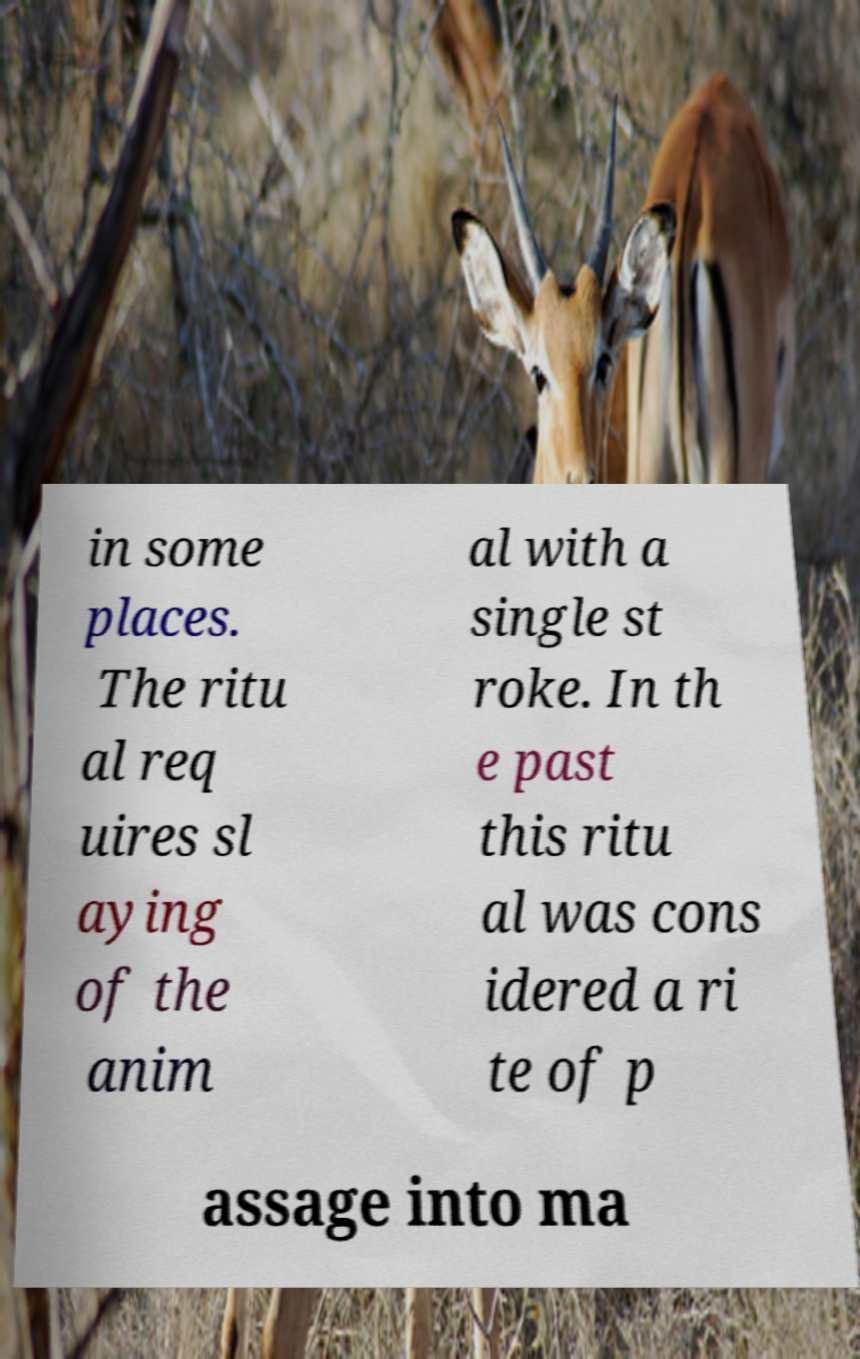What messages or text are displayed in this image? I need them in a readable, typed format. in some places. The ritu al req uires sl aying of the anim al with a single st roke. In th e past this ritu al was cons idered a ri te of p assage into ma 